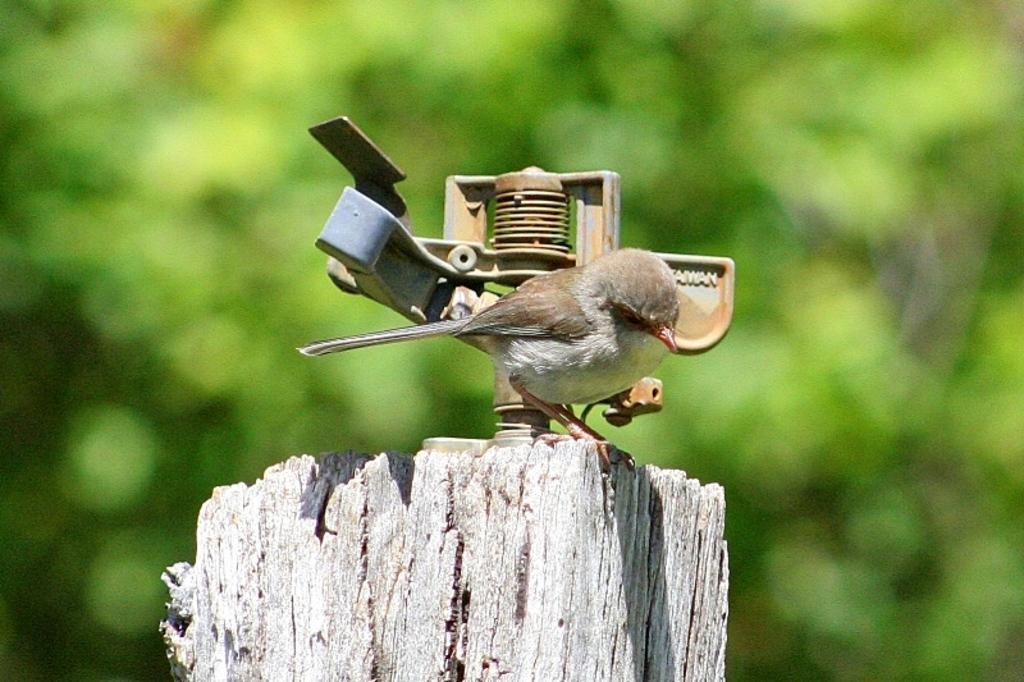Please provide a concise description of this image. In this picture we can see a bird is standing, at the bottom there is wood, it looks like a tree in the background, we can see a blurry background. 